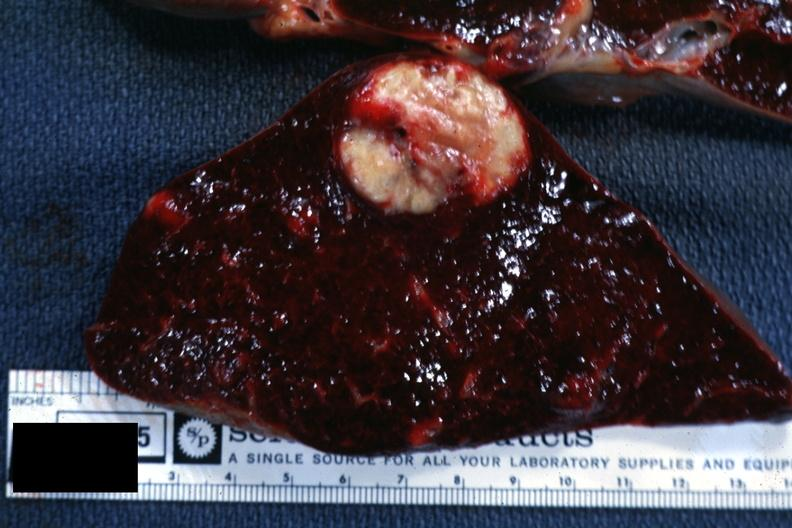where is this part in?
Answer the question using a single word or phrase. Spleen 